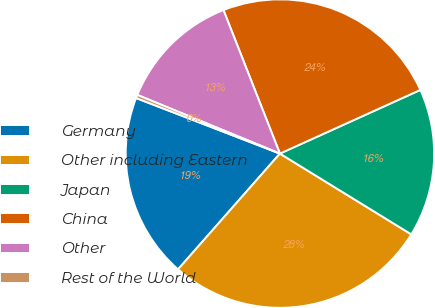<chart> <loc_0><loc_0><loc_500><loc_500><pie_chart><fcel>Germany<fcel>Other including Eastern<fcel>Japan<fcel>China<fcel>Other<fcel>Rest of the World<nl><fcel>19.38%<fcel>27.71%<fcel>15.55%<fcel>24.19%<fcel>12.82%<fcel>0.35%<nl></chart> 